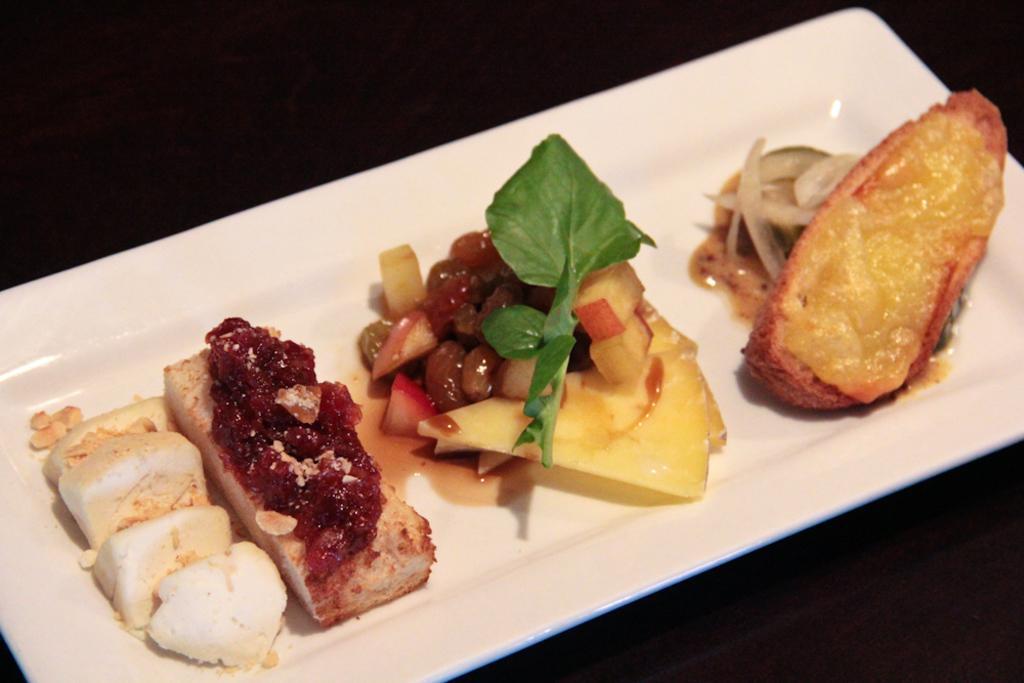In one or two sentences, can you explain what this image depicts? We can see tray with food. In the background it is dark. 